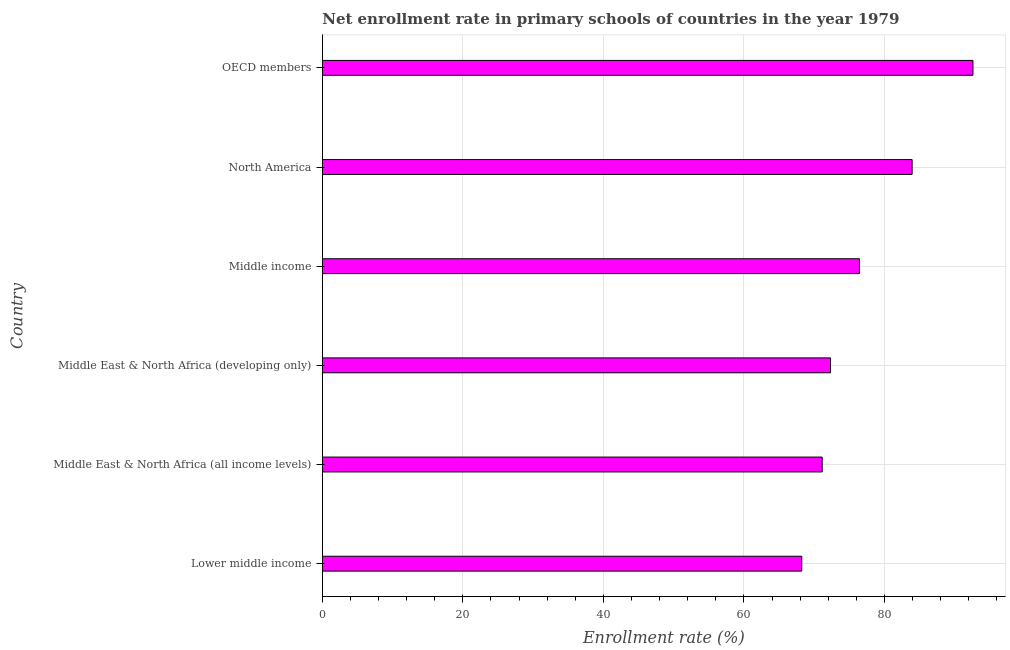Does the graph contain any zero values?
Provide a succinct answer. No. Does the graph contain grids?
Make the answer very short. Yes. What is the title of the graph?
Ensure brevity in your answer.  Net enrollment rate in primary schools of countries in the year 1979. What is the label or title of the X-axis?
Ensure brevity in your answer.  Enrollment rate (%). What is the label or title of the Y-axis?
Make the answer very short. Country. What is the net enrollment rate in primary schools in OECD members?
Offer a very short reply. 92.6. Across all countries, what is the maximum net enrollment rate in primary schools?
Your answer should be compact. 92.6. Across all countries, what is the minimum net enrollment rate in primary schools?
Provide a short and direct response. 68.24. In which country was the net enrollment rate in primary schools maximum?
Give a very brief answer. OECD members. In which country was the net enrollment rate in primary schools minimum?
Ensure brevity in your answer.  Lower middle income. What is the sum of the net enrollment rate in primary schools?
Provide a short and direct response. 464.68. What is the difference between the net enrollment rate in primary schools in Lower middle income and Middle East & North Africa (developing only)?
Your answer should be very brief. -4.09. What is the average net enrollment rate in primary schools per country?
Provide a succinct answer. 77.45. What is the median net enrollment rate in primary schools?
Your response must be concise. 74.38. What is the ratio of the net enrollment rate in primary schools in Middle income to that in OECD members?
Ensure brevity in your answer.  0.82. What is the difference between the highest and the second highest net enrollment rate in primary schools?
Offer a terse response. 8.66. Is the sum of the net enrollment rate in primary schools in Lower middle income and Middle East & North Africa (all income levels) greater than the maximum net enrollment rate in primary schools across all countries?
Provide a succinct answer. Yes. What is the difference between the highest and the lowest net enrollment rate in primary schools?
Ensure brevity in your answer.  24.36. In how many countries, is the net enrollment rate in primary schools greater than the average net enrollment rate in primary schools taken over all countries?
Ensure brevity in your answer.  2. What is the difference between two consecutive major ticks on the X-axis?
Keep it short and to the point. 20. What is the Enrollment rate (%) of Lower middle income?
Your answer should be very brief. 68.24. What is the Enrollment rate (%) of Middle East & North Africa (all income levels)?
Ensure brevity in your answer.  71.14. What is the Enrollment rate (%) in Middle East & North Africa (developing only)?
Keep it short and to the point. 72.33. What is the Enrollment rate (%) in Middle income?
Your answer should be very brief. 76.44. What is the Enrollment rate (%) in North America?
Provide a succinct answer. 83.94. What is the Enrollment rate (%) of OECD members?
Make the answer very short. 92.6. What is the difference between the Enrollment rate (%) in Lower middle income and Middle East & North Africa (all income levels)?
Your answer should be compact. -2.91. What is the difference between the Enrollment rate (%) in Lower middle income and Middle East & North Africa (developing only)?
Offer a very short reply. -4.09. What is the difference between the Enrollment rate (%) in Lower middle income and Middle income?
Ensure brevity in your answer.  -8.2. What is the difference between the Enrollment rate (%) in Lower middle income and North America?
Keep it short and to the point. -15.71. What is the difference between the Enrollment rate (%) in Lower middle income and OECD members?
Your response must be concise. -24.36. What is the difference between the Enrollment rate (%) in Middle East & North Africa (all income levels) and Middle East & North Africa (developing only)?
Make the answer very short. -1.19. What is the difference between the Enrollment rate (%) in Middle East & North Africa (all income levels) and Middle income?
Offer a very short reply. -5.3. What is the difference between the Enrollment rate (%) in Middle East & North Africa (all income levels) and North America?
Your response must be concise. -12.8. What is the difference between the Enrollment rate (%) in Middle East & North Africa (all income levels) and OECD members?
Your answer should be compact. -21.46. What is the difference between the Enrollment rate (%) in Middle East & North Africa (developing only) and Middle income?
Your answer should be very brief. -4.11. What is the difference between the Enrollment rate (%) in Middle East & North Africa (developing only) and North America?
Ensure brevity in your answer.  -11.61. What is the difference between the Enrollment rate (%) in Middle East & North Africa (developing only) and OECD members?
Ensure brevity in your answer.  -20.27. What is the difference between the Enrollment rate (%) in Middle income and North America?
Your response must be concise. -7.5. What is the difference between the Enrollment rate (%) in Middle income and OECD members?
Provide a short and direct response. -16.16. What is the difference between the Enrollment rate (%) in North America and OECD members?
Make the answer very short. -8.66. What is the ratio of the Enrollment rate (%) in Lower middle income to that in Middle East & North Africa (all income levels)?
Ensure brevity in your answer.  0.96. What is the ratio of the Enrollment rate (%) in Lower middle income to that in Middle East & North Africa (developing only)?
Keep it short and to the point. 0.94. What is the ratio of the Enrollment rate (%) in Lower middle income to that in Middle income?
Ensure brevity in your answer.  0.89. What is the ratio of the Enrollment rate (%) in Lower middle income to that in North America?
Give a very brief answer. 0.81. What is the ratio of the Enrollment rate (%) in Lower middle income to that in OECD members?
Offer a very short reply. 0.74. What is the ratio of the Enrollment rate (%) in Middle East & North Africa (all income levels) to that in Middle East & North Africa (developing only)?
Offer a very short reply. 0.98. What is the ratio of the Enrollment rate (%) in Middle East & North Africa (all income levels) to that in North America?
Provide a succinct answer. 0.85. What is the ratio of the Enrollment rate (%) in Middle East & North Africa (all income levels) to that in OECD members?
Make the answer very short. 0.77. What is the ratio of the Enrollment rate (%) in Middle East & North Africa (developing only) to that in Middle income?
Give a very brief answer. 0.95. What is the ratio of the Enrollment rate (%) in Middle East & North Africa (developing only) to that in North America?
Provide a short and direct response. 0.86. What is the ratio of the Enrollment rate (%) in Middle East & North Africa (developing only) to that in OECD members?
Your answer should be compact. 0.78. What is the ratio of the Enrollment rate (%) in Middle income to that in North America?
Provide a succinct answer. 0.91. What is the ratio of the Enrollment rate (%) in Middle income to that in OECD members?
Offer a very short reply. 0.82. What is the ratio of the Enrollment rate (%) in North America to that in OECD members?
Your answer should be compact. 0.91. 